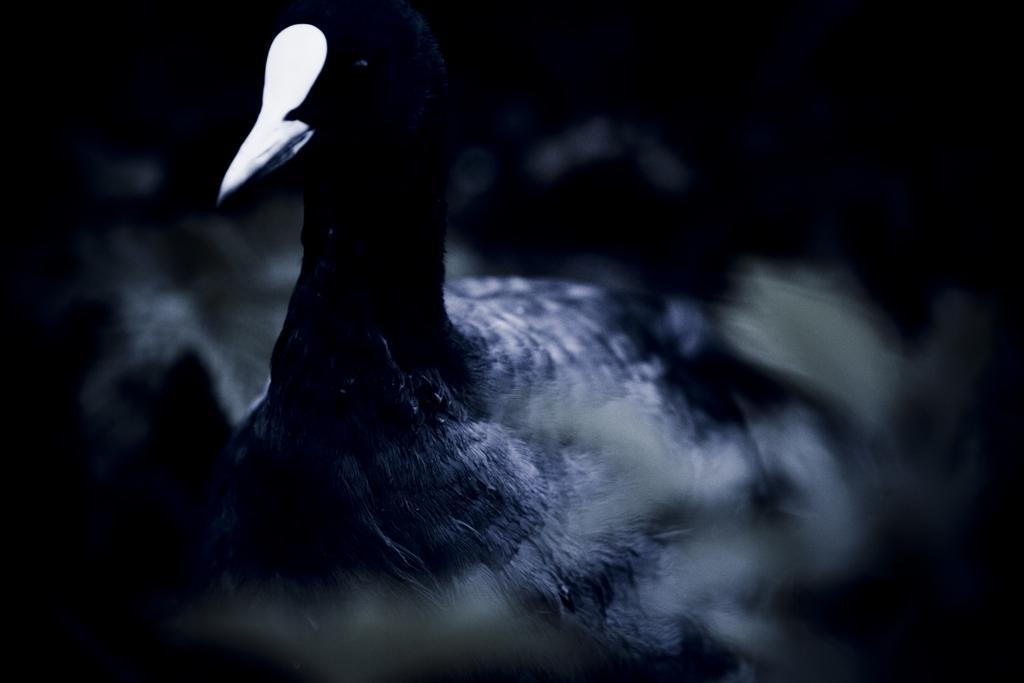In one or two sentences, can you explain what this image depicts? In this image I can see in the middle there is a bird in black color. 